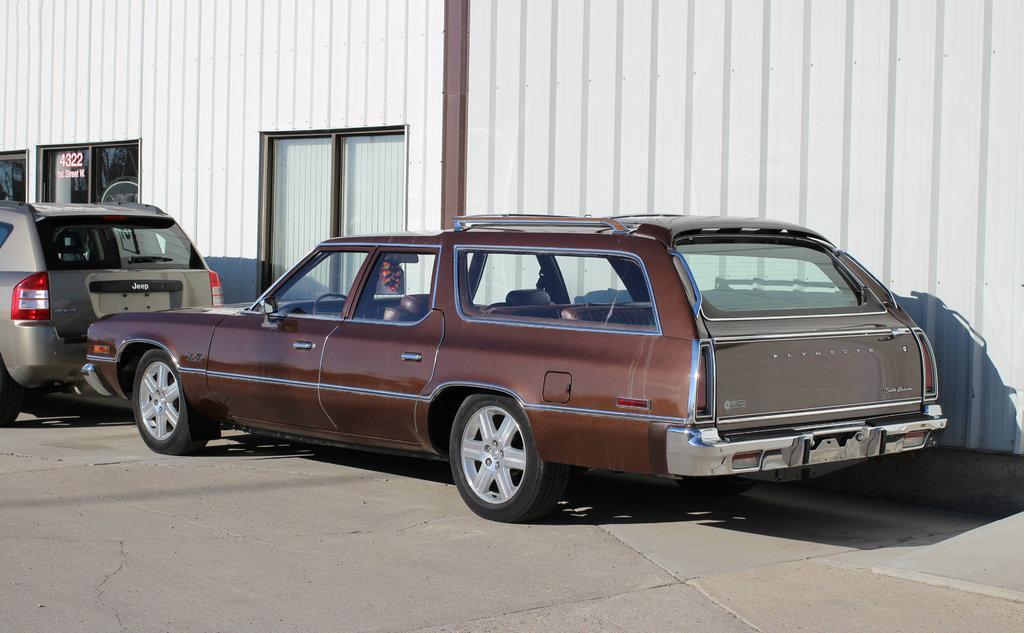Please provide a concise description of this image. This picture is clicked outside. In the center we can see the cars parked on the ground. In the background we can see the metal objects and the windows. 